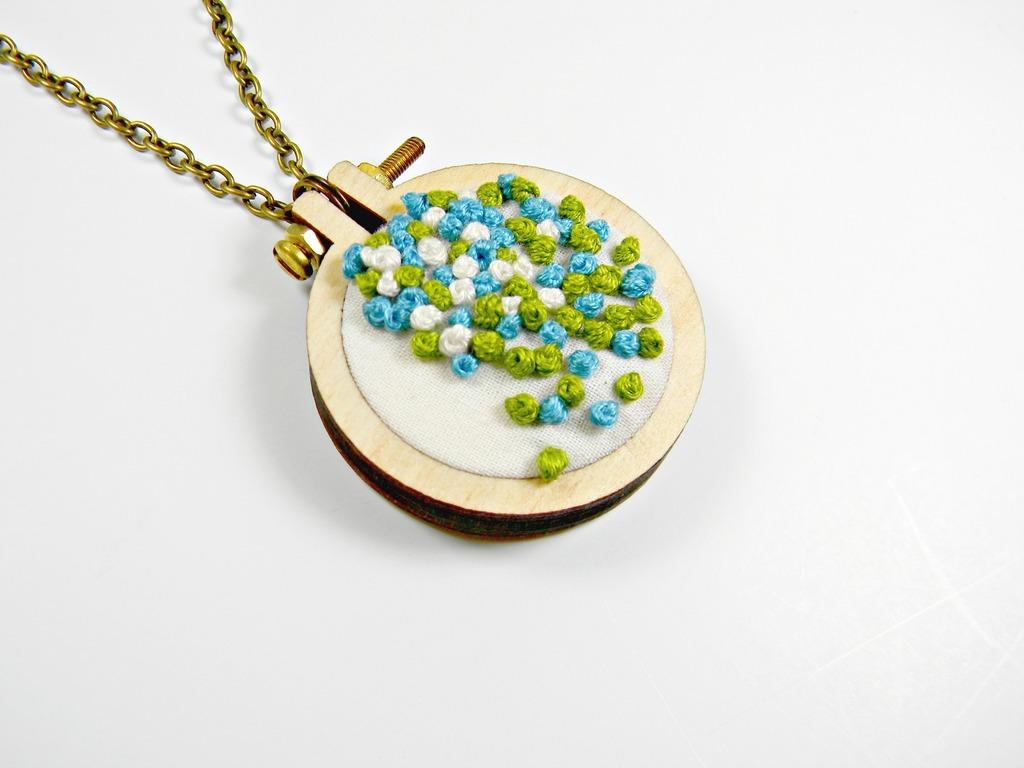What type of jewelry is visible in the image? There is a neck chain in the image. What material is the neck chain made of? The neck chain is made of steel. What other items can be seen in the image related to the neck chain? There is a hex bolt, a nut, and a pendant in the image. Where is the faucet located in the image? There is no faucet present in the image. What type of fiction is being read by the zebra in the image? There is no zebra or fiction in the image. 